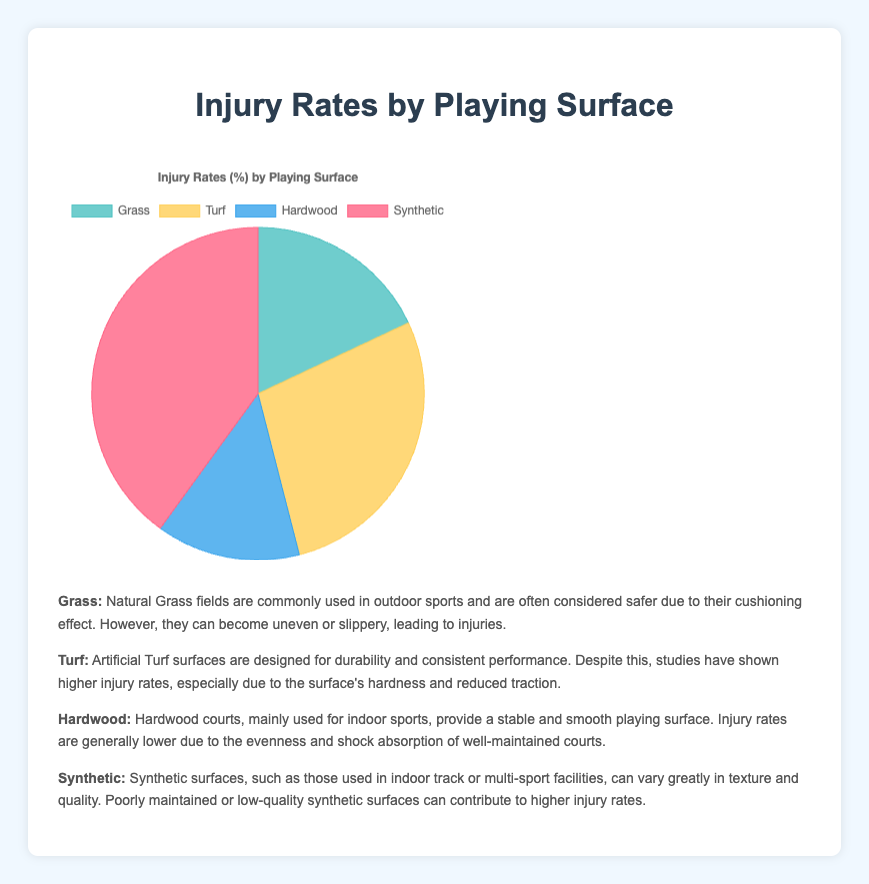Which playing surface has the highest injury rate? Looking at the pie chart, the segment with the highest percentage is for Synthetic surfaces.
Answer: Synthetic Which playing surface has the lowest injury rate? From the pie chart, the smallest segment is for Hardwood surfaces, indicating the lowest injury rate.
Answer: Hardwood How much greater is the injury rate for Turf compared to Grass? The injury rate for Turf is 28% and for Grass it is 18%. The difference is 28% - 18% = 10%.
Answer: 10% Which two surfaces combined account for more than half of the injuries? Adding the injury rates, Synthetic has 40% and Turf has 28%. Together, they account for 40% + 28% = 68%, which is more than half.
Answer: Synthetic and Turf What is the combined injury rate for Grass and Hardwood? The injury rate for Grass is 18% and for Hardwood it is 14%. The sum is 18% + 14% = 32%.
Answer: 32% Is the injury rate on Turf higher or lower than the average injury rate across all surfaces? To find the average injury rate, sum all injury rates (18% + 28% + 14% + 40% = 100%) and divide by 4 (100%/4 = 25%). The injury rate on Turf is 28%, which is higher than the average of 25%.
Answer: Higher Which colored segment represents Grass? The segment representing Grass is colored in a shade of green.
Answer: Green Is the injury rate for Synthetic surfaces more than twice the rate for Hardwood? The injury rate for Synthetic surfaces is 40%. The injury rate for Hardwood is 14%. To check, compare 40% to twice of 14% (which is 28%). Since 40% is greater than 28%, yes, it is more than twice.
Answer: Yes What is the difference between the highest and lowest injury rates? The highest injury rate is 40% (Synthetic) and the lowest is 14% (Hardwood). The difference is 40% - 14% = 26%.
Answer: 26% What percentage of injuries occur on natural surfaces (Grass and Hardwood combined)? Grass has an 18% injury rate and Hardwood has a 14%. Adding these, the total is 18% + 14% = 32%.
Answer: 32% 